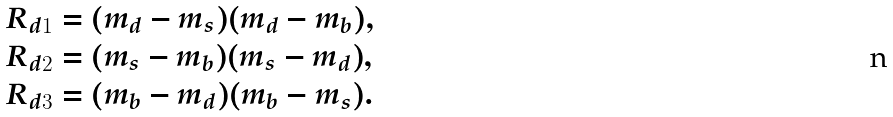Convert formula to latex. <formula><loc_0><loc_0><loc_500><loc_500>R _ { d 1 } & = ( m _ { d } - m _ { s } ) ( m _ { d } - m _ { b } ) , \\ R _ { d 2 } & = ( m _ { s } - m _ { b } ) ( m _ { s } - m _ { d } ) , \\ R _ { d 3 } & = ( m _ { b } - m _ { d } ) ( m _ { b } - m _ { s } ) .</formula> 